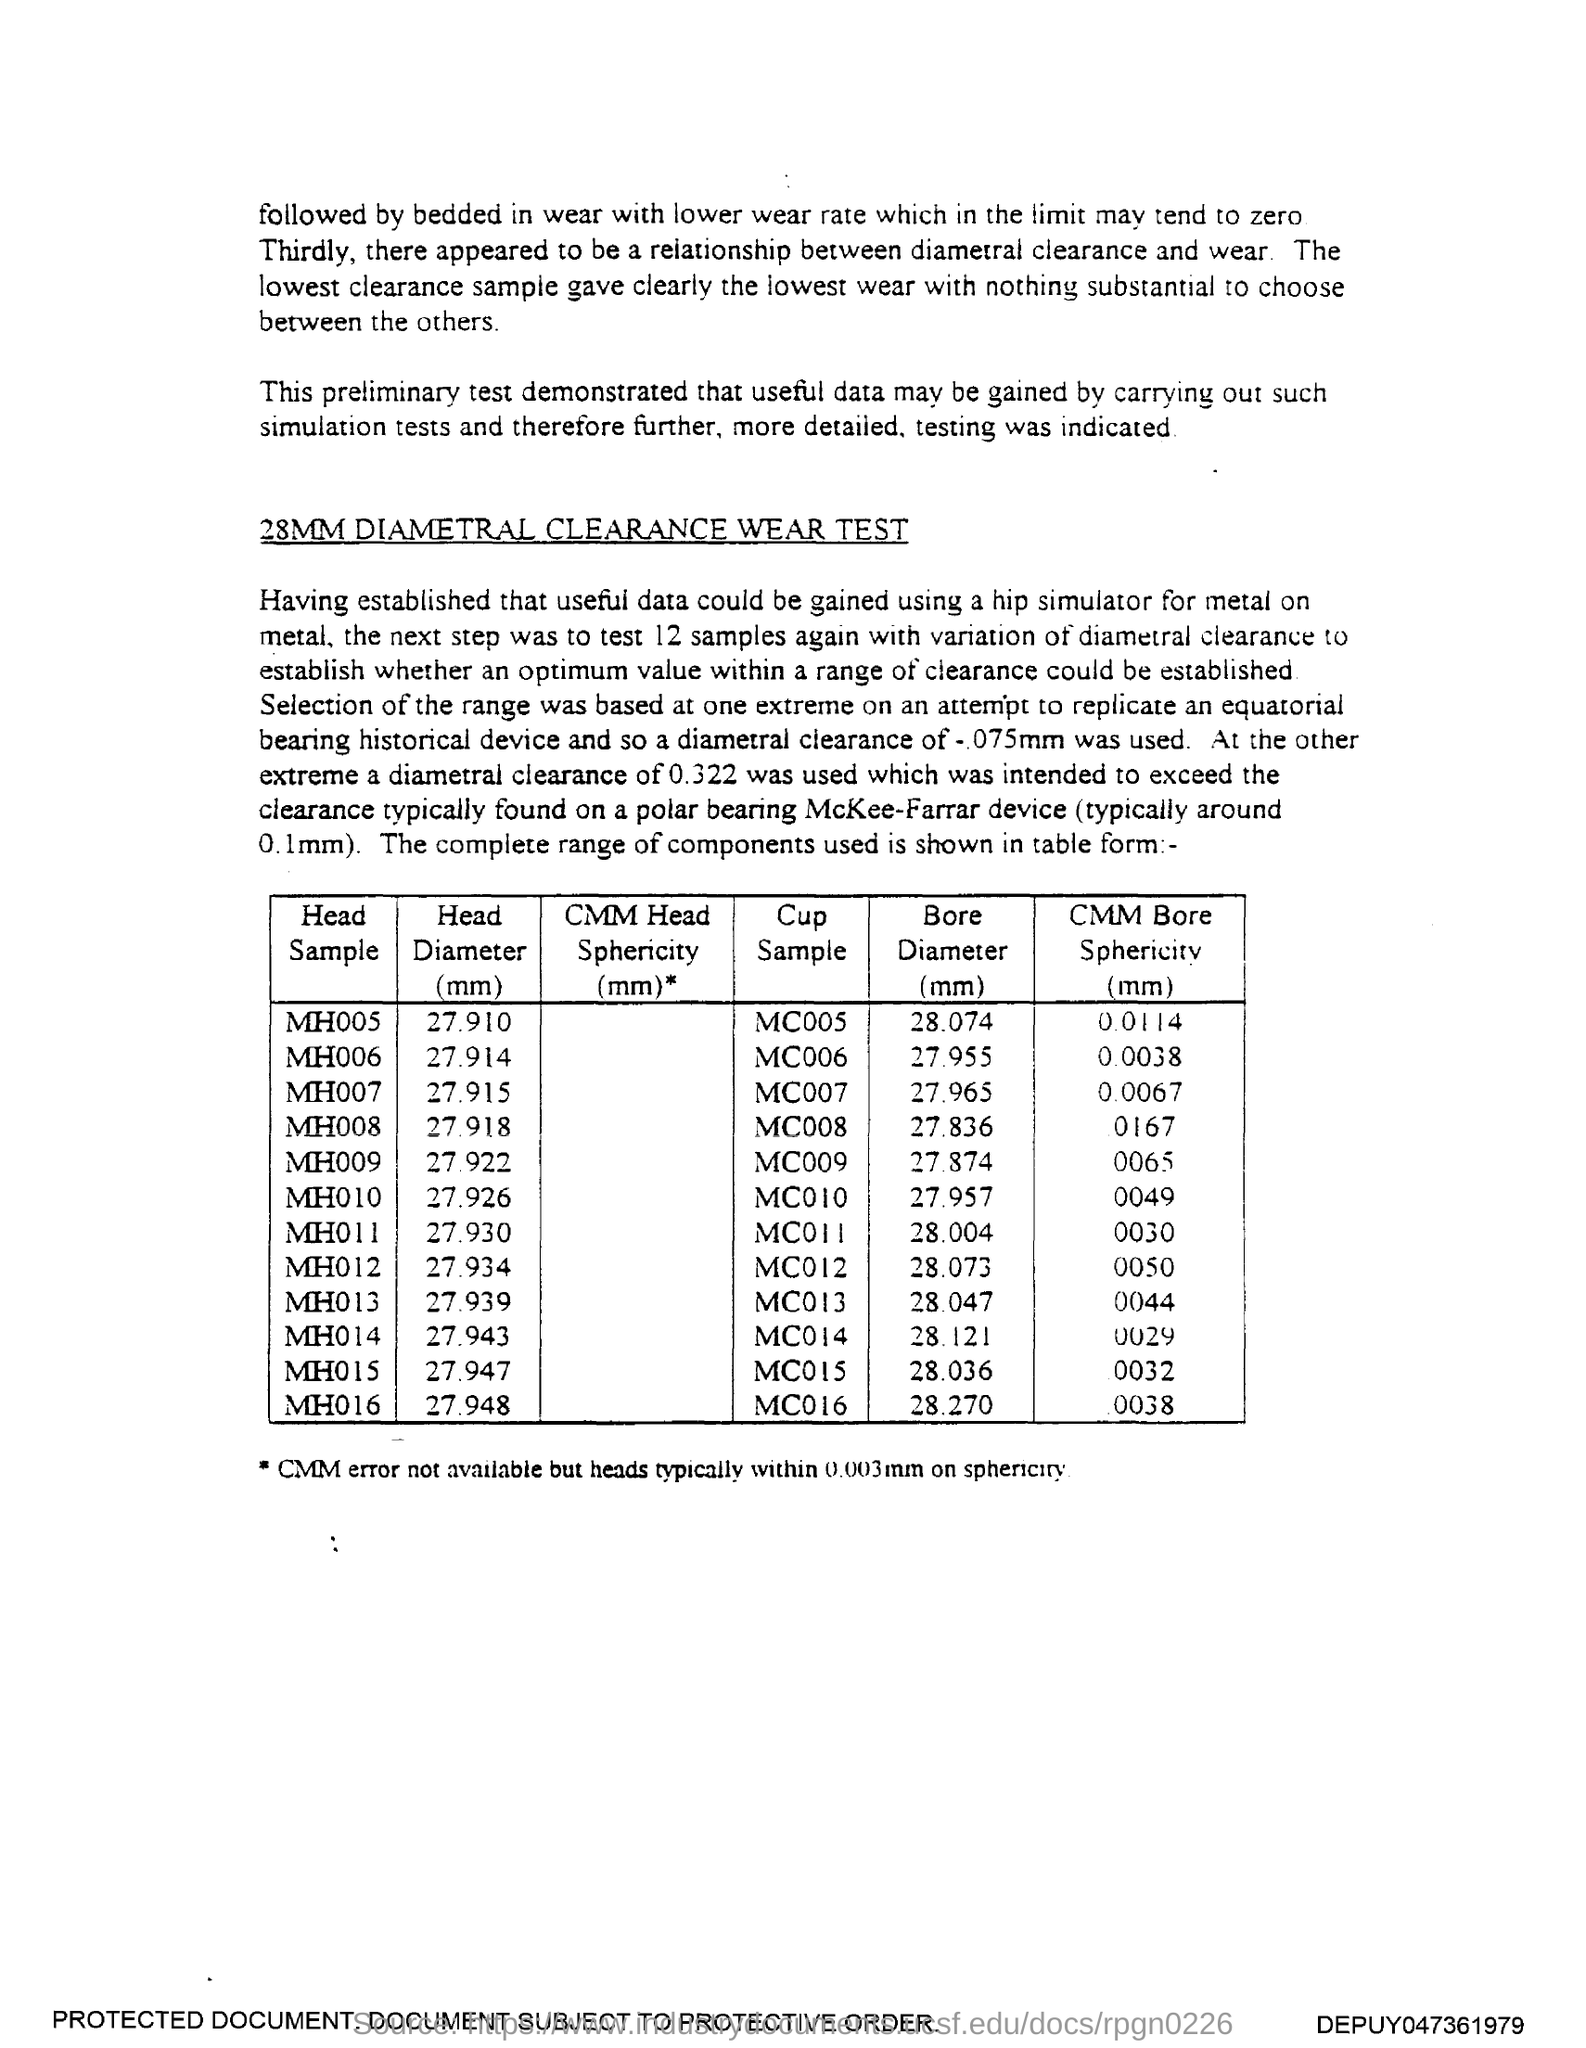List a handful of essential elements in this visual. The head sample MH010 has a head diameter of 27.926 millimeters. The head diameter for the head sample MH009 is 27.922 millimeters. The Head Diameter for Head Sample MH005 is 27.910 millimeters. The head diameter for head sample MH014 is 27.943 millimeters (mm). The head diameter for the head sample MH007 is 27.915 millimeters. 